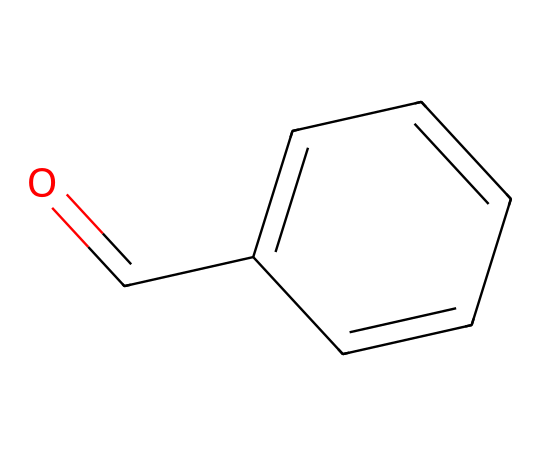What is the molecular formula of this chemical? The molecular formula can be determined by counting the number of carbon (C), hydrogen (H), and oxygen (O) atoms in the chemical structure. There are six carbons, five hydrogens, and one oxygen atom. Therefore, the molecular formula is C7H6O.
Answer: C7H6O How many carbon atoms are present in benzaldehyde? By examining the chemical structure, we can see there are six carbon atoms in the benzene ring and one carbon from the aldehyde functional group, making a total of seven carbon atoms.
Answer: 7 What type of functional group is present in benzaldehyde? The chemical structure contains a carbonyl group (C=O) attached to a carbon of the benzene ring, which classifies it as an aldehyde due to the presence of the aldehydic hydrogen.
Answer: aldehyde What is the total number of hydrogen atoms in benzaldehyde? The structure shows that there are five hydrogen atoms attached to the benzene ring and one on the aldehyde group, giving a total of six hydrogen atoms in benzaldehyde.
Answer: 6 How does benzaldehyde contribute to the scent in leather treatments? The aromatic ring system in benzaldehyde is known for its distinct scent due to the conjugated system that enhances volatility and aroma. This contributes to the characteristic scent found in leather treatments.
Answer: scent What is the primary use of benzaldehyde in leather treatments? Benzaldehyde is primarily used as a solvent and a fragrance agent in leather treatments, contributing to the preservation and scent of vintage leather goods.
Answer: solvent, fragrance 